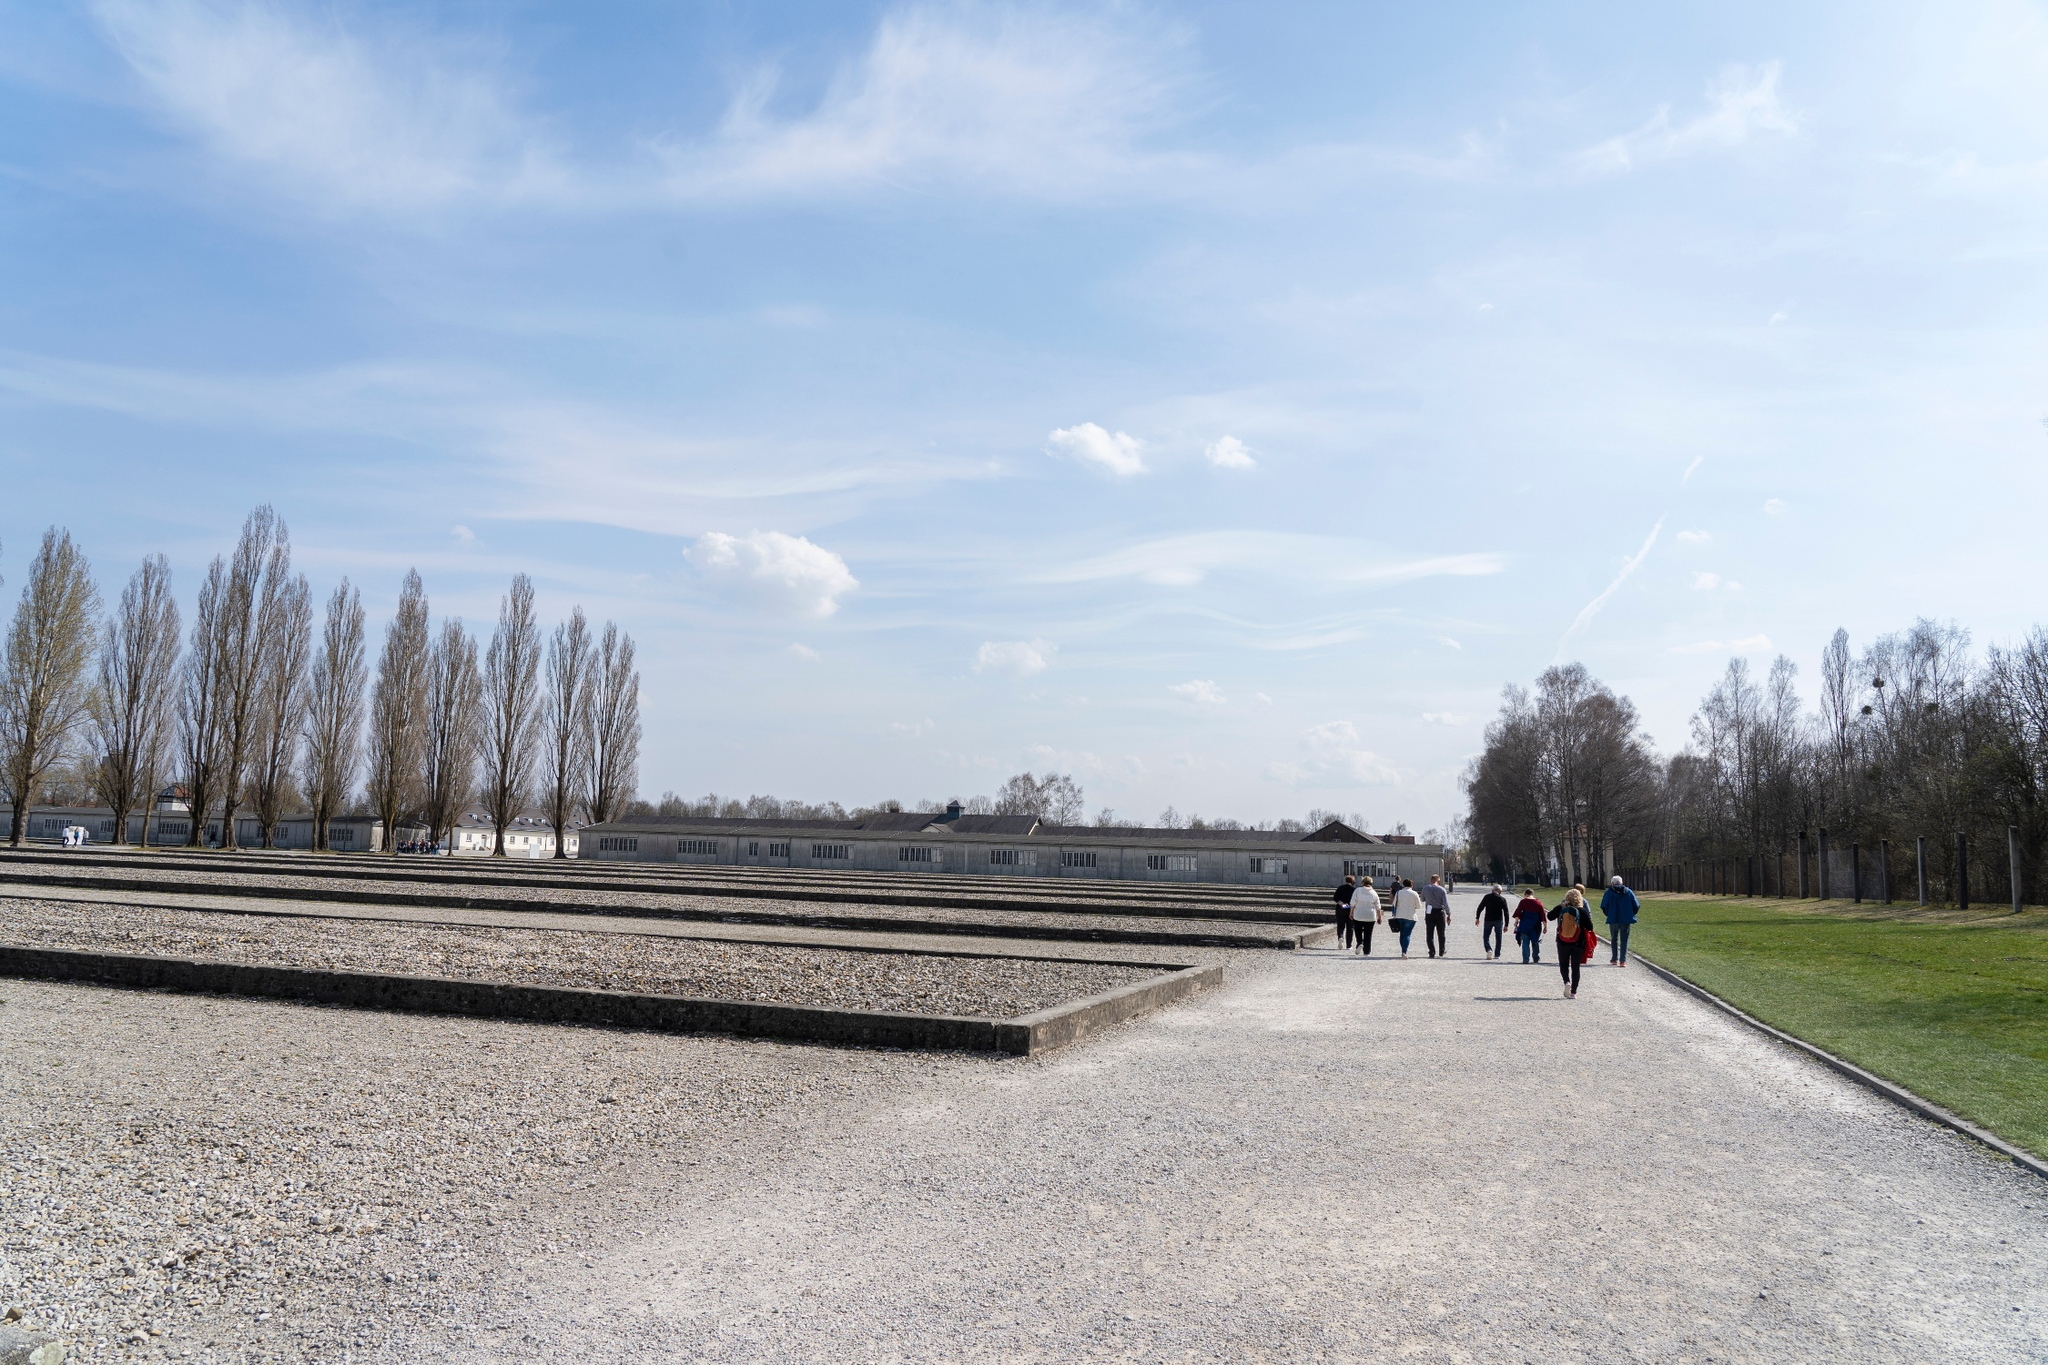What kind of emotional atmosphere does the place in the image evoke? The image evokes a mix of solemnity and quiet reflection. The formal arrangement of the memorial site, coupled with the presence of a small group of visitors, suggests a place of remembrance and respect. The clear blue sky and budding greenery, however, lend a sense of tranquil renewal and resilience. This juxtaposition between the somber historical context and the peaceful natural surrounding creates a deeply poignant emotional atmosphere. 